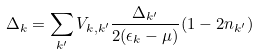<formula> <loc_0><loc_0><loc_500><loc_500>\Delta _ { k } = \sum _ { k ^ { \prime } } V _ { k , k ^ { \prime } } \frac { \Delta _ { k ^ { \prime } } } { 2 ( \epsilon _ { k } - \mu ) } ( 1 - 2 n _ { k ^ { \prime } } )</formula> 